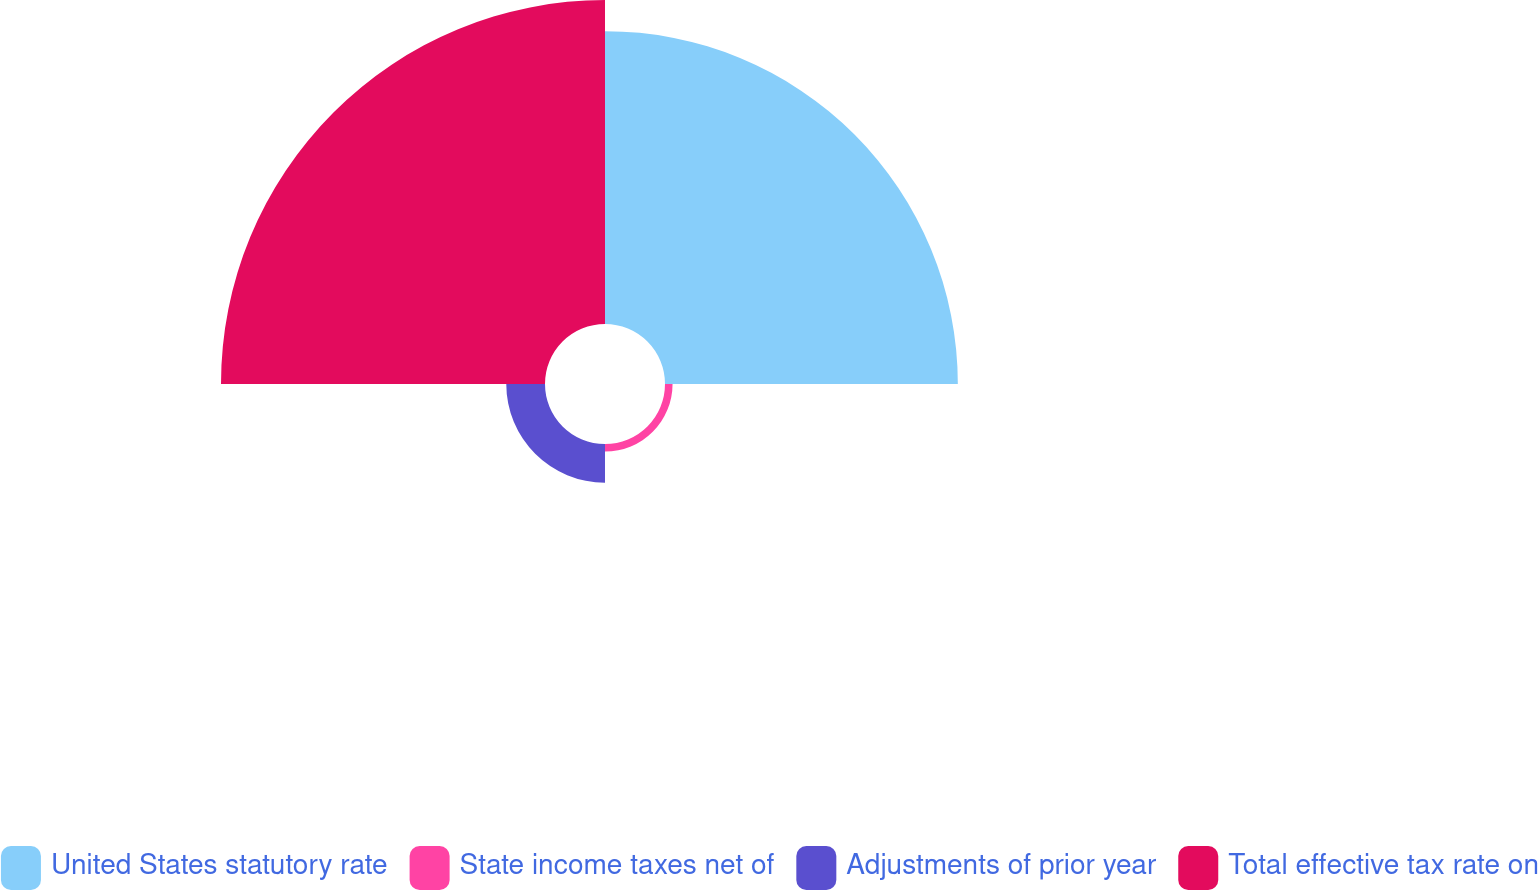<chart> <loc_0><loc_0><loc_500><loc_500><pie_chart><fcel>United States statutory rate<fcel>State income taxes net of<fcel>Adjustments of prior year<fcel>Total effective tax rate on<nl><fcel>44.16%<fcel>1.14%<fcel>5.84%<fcel>48.86%<nl></chart> 